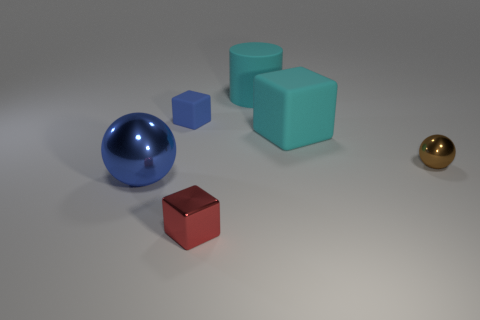Add 1 blue matte cylinders. How many objects exist? 7 Subtract all rubber blocks. How many blocks are left? 1 Subtract all brown balls. How many balls are left? 1 Subtract 0 blue cylinders. How many objects are left? 6 Subtract all spheres. How many objects are left? 4 Subtract 1 cylinders. How many cylinders are left? 0 Subtract all blue cylinders. Subtract all purple balls. How many cylinders are left? 1 Subtract all purple blocks. How many yellow cylinders are left? 0 Subtract all small gray cylinders. Subtract all small blue matte objects. How many objects are left? 5 Add 2 large matte things. How many large matte things are left? 4 